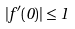<formula> <loc_0><loc_0><loc_500><loc_500>| f ^ { \prime } ( 0 ) | \leq 1</formula> 